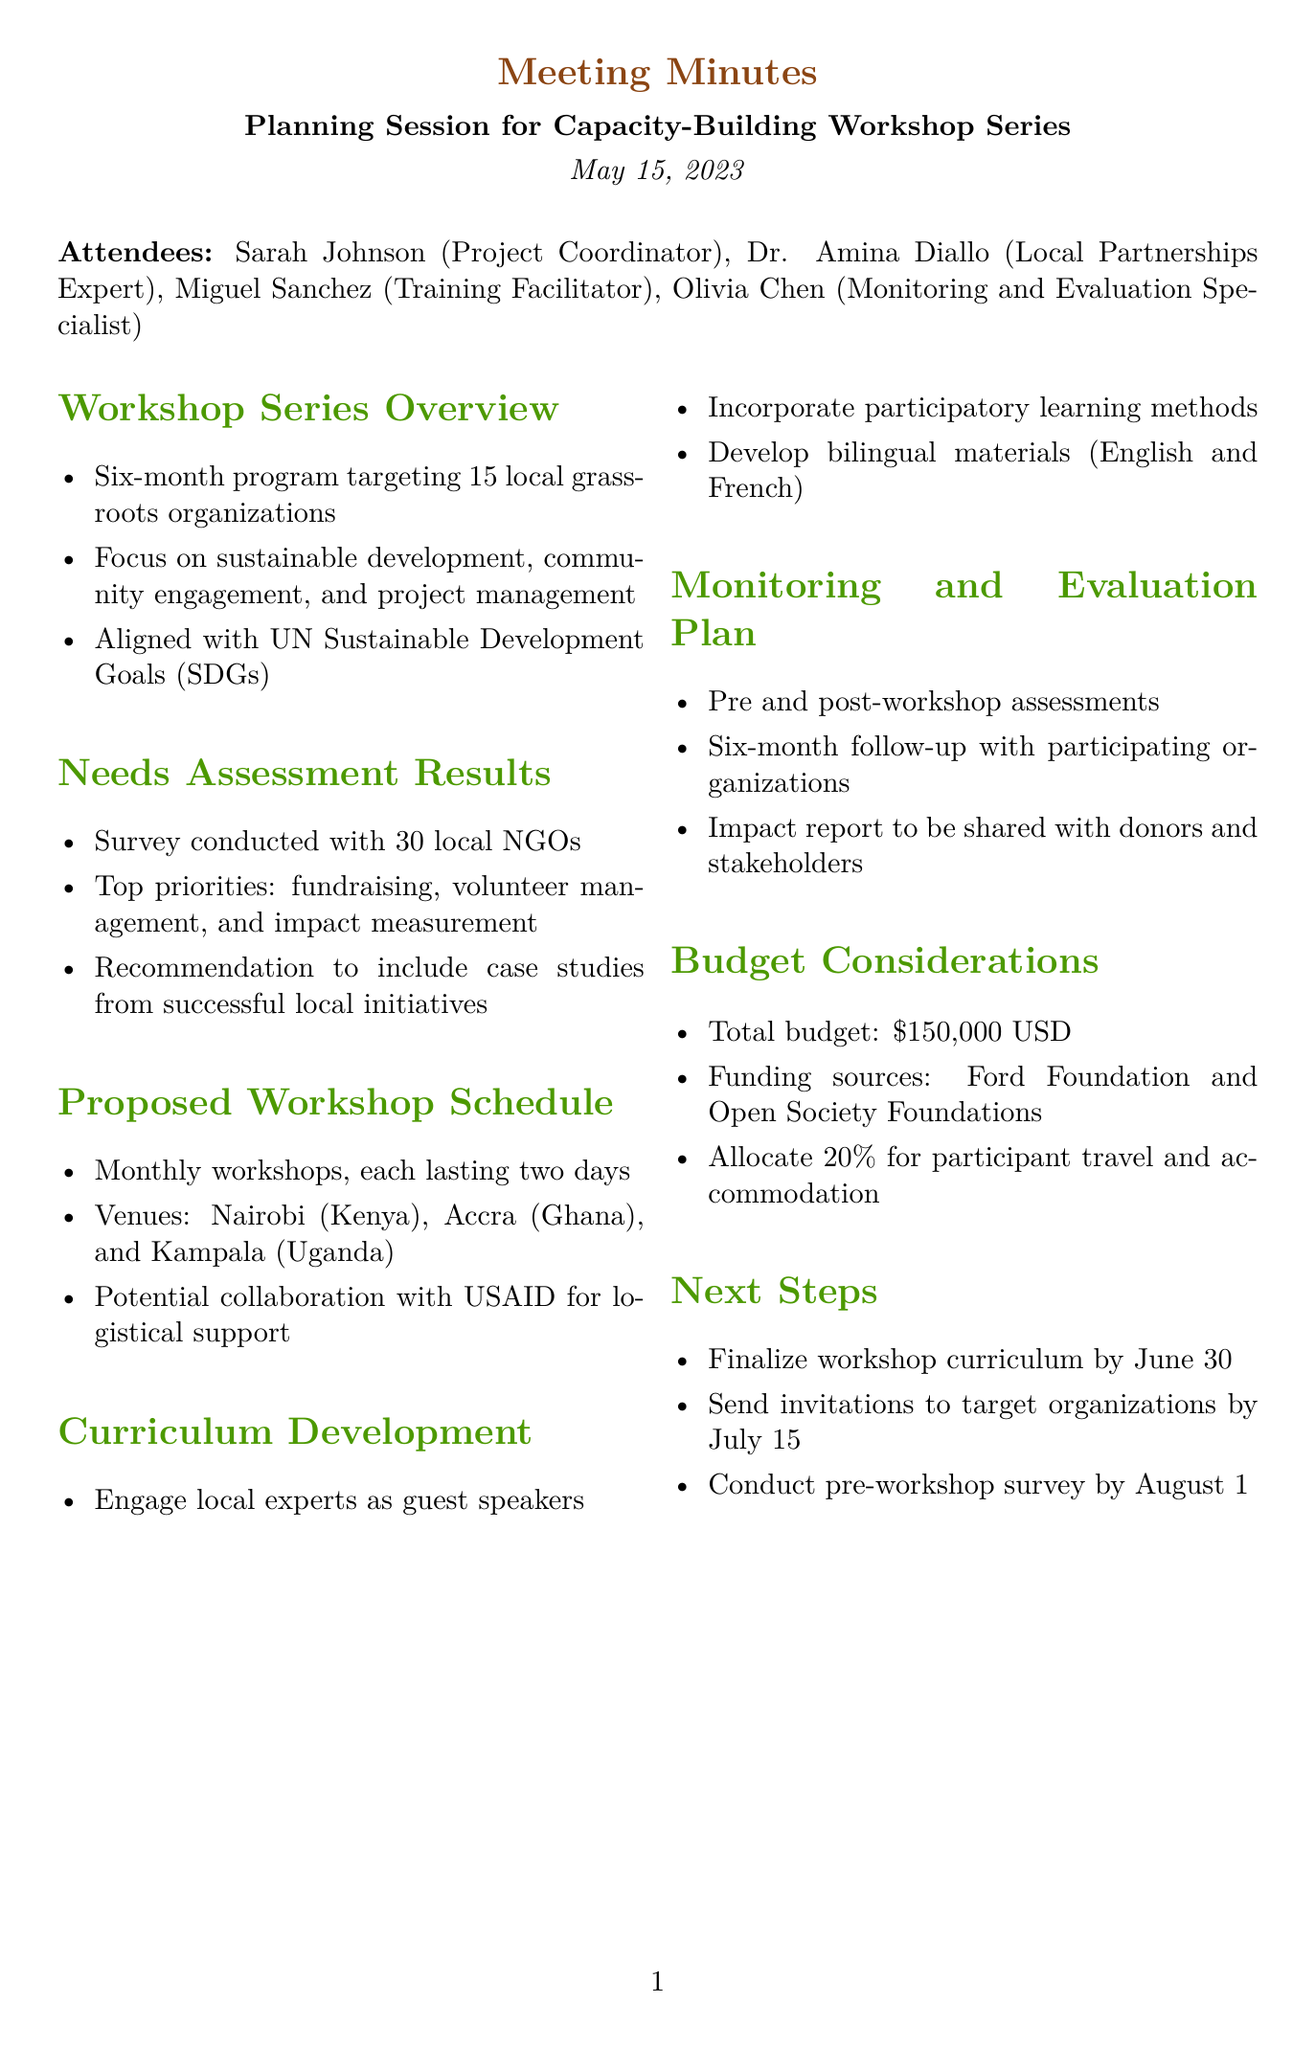What is the date of the meeting? The date of the meeting is specified in the document as May 15, 2023.
Answer: May 15, 2023 How many local grassroots organizations are targeted in the workshop series? The document states that the program targets 15 local grassroots organizations.
Answer: 15 What is the focus of the capacity-building workshop series? The focus areas of the workshop series, as noted in the document, include sustainable development, community engagement, and project management.
Answer: Sustainable development, community engagement, and project management What are the top priorities identified in the needs assessment results? The needs assessment highlights fundraising, volunteer management, and impact measurement as the top priorities among local NGOs.
Answer: Fundraising, volunteer management, and impact measurement What is the total budget allocated for the workshop series? The total budget for the workshop series is reported as 150,000 USD in the document.
Answer: 150,000 USD Which countries will host the workshops? The venues for the workshops listed in the document are Nairobi (Kenya), Accra (Ghana), and Kampala (Uganda).
Answer: Nairobi, Accra, and Kampala When is the workshop curriculum expected to be finalized? The document mentions that the workshop curriculum should be finalized by June 30.
Answer: June 30 How many months will the workshop series run? The workshop series is described as a six-month program in the document.
Answer: Six months What will the impact report be used for? The impact report is intended to be shared with donors and stakeholders as outlined in the document.
Answer: Shared with donors and stakeholders 